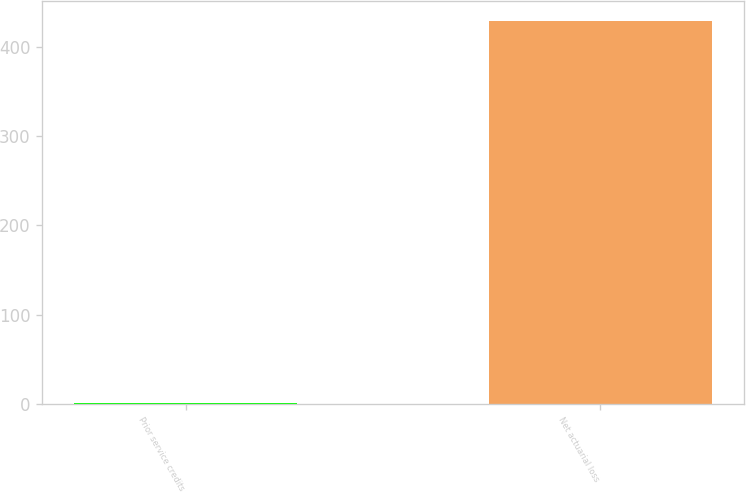Convert chart. <chart><loc_0><loc_0><loc_500><loc_500><bar_chart><fcel>Prior service credits<fcel>Net actuarial loss<nl><fcel>1<fcel>429<nl></chart> 